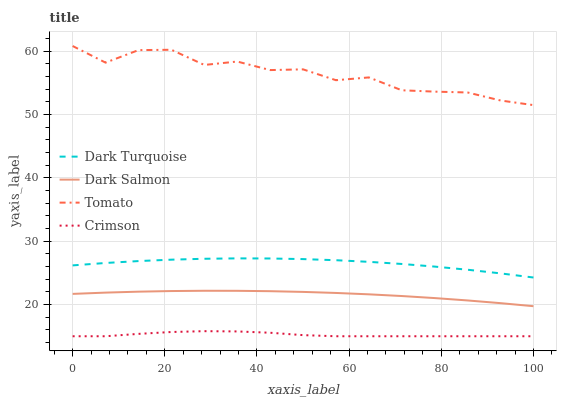Does Dark Turquoise have the minimum area under the curve?
Answer yes or no. No. Does Dark Turquoise have the maximum area under the curve?
Answer yes or no. No. Is Dark Turquoise the smoothest?
Answer yes or no. No. Is Dark Turquoise the roughest?
Answer yes or no. No. Does Dark Turquoise have the lowest value?
Answer yes or no. No. Does Dark Turquoise have the highest value?
Answer yes or no. No. Is Dark Salmon less than Tomato?
Answer yes or no. Yes. Is Tomato greater than Dark Turquoise?
Answer yes or no. Yes. Does Dark Salmon intersect Tomato?
Answer yes or no. No. 